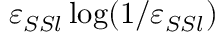Convert formula to latex. <formula><loc_0><loc_0><loc_500><loc_500>\varepsilon _ { S S l } \log ( 1 / \varepsilon _ { S S l } )</formula> 